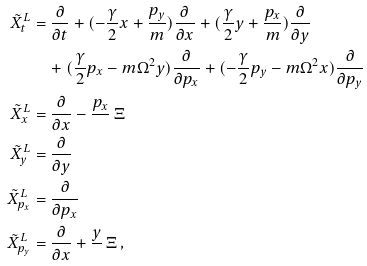Convert formula to latex. <formula><loc_0><loc_0><loc_500><loc_500>\tilde { X } _ { t } ^ { L } & = \frac { \partial } { \partial t } + ( - \frac { \gamma } { 2 } x + \frac { p _ { y } } { m } ) \frac { \partial } { \partial x } + ( \frac { \gamma } { 2 } y + \frac { p _ { x } } { m } ) \frac { \partial } { \partial y } \\ & \quad + ( \frac { \gamma } { 2 } p _ { x } - m \Omega ^ { 2 } y ) \frac { \partial } { \partial p _ { x } } + ( - \frac { \gamma } { 2 } p _ { y } - m \Omega ^ { 2 } x ) \frac { \partial } { \partial p _ { y } } \\ \tilde { X } _ { x } ^ { L } & = \frac { \partial } { \partial x } - \frac { p _ { x } } { } \, \Xi \\ \tilde { X } _ { y } ^ { L } & = \frac { \partial } { \partial y } \\ \tilde { X } _ { p _ { x } } ^ { L } & = \frac { \partial } { \partial p _ { x } } \\ \tilde { X } _ { p _ { y } } ^ { L } & = \frac { \partial } { \partial x } + \frac { y } { } \, \Xi \, ,</formula> 